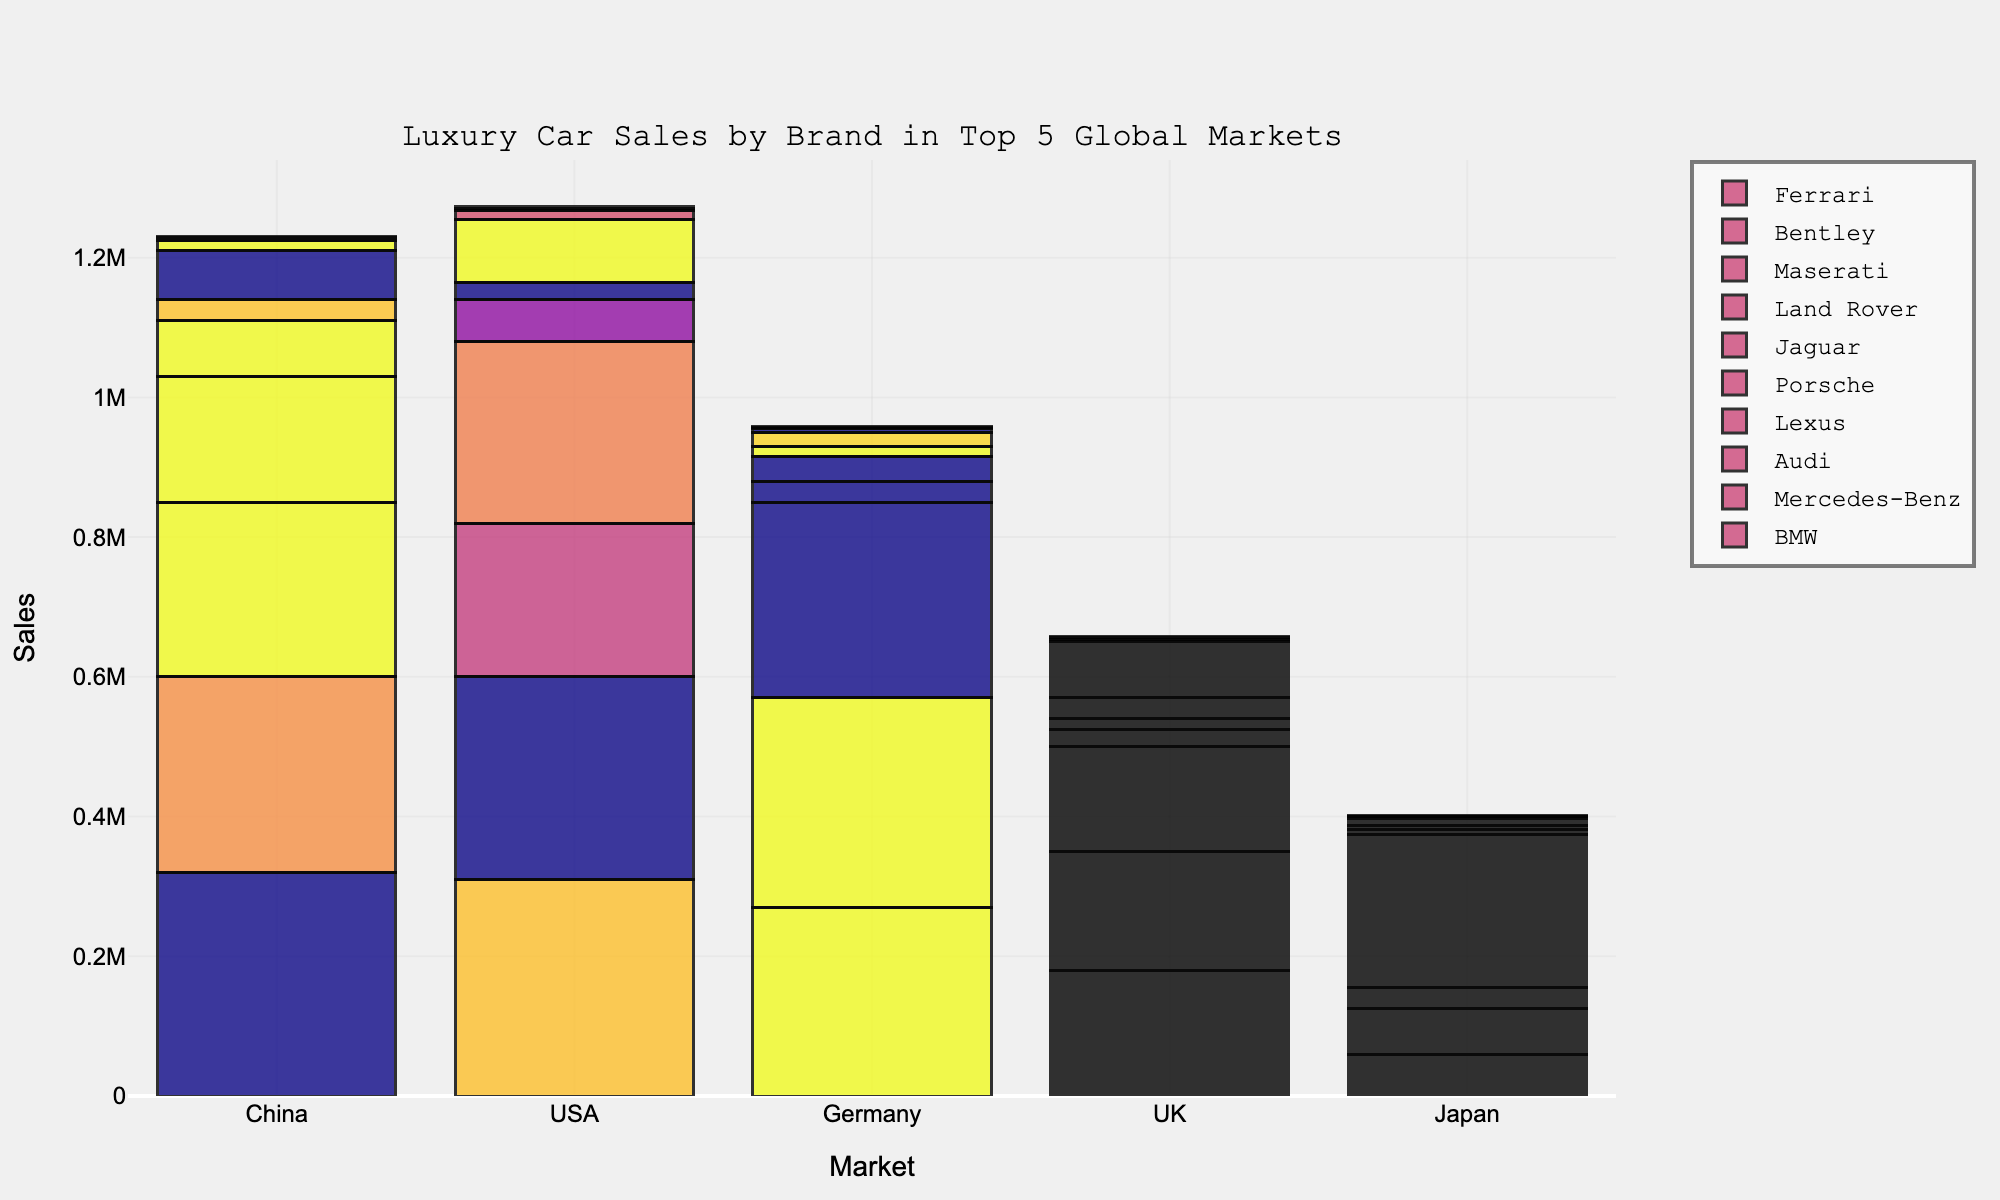What is the total number of luxury cars sold by BMW across the top 5 global markets? Add up BMW sales in China, USA, Germany, UK, and Japan: (320,000 + 310,000 + 270,000 + 180,000 + 60,000)
Answer: 1,140,000 Which brand has the highest sales in Japan? Check the sales figures for all brands in Japan; Lexus has the highest with 220,000 units.
Answer: Lexus How do Porsche's sales in the USA compare to its sales in Germany? Compare Porsche's sales in the USA (60,000) to its sales in Germany (35,000); 60,000 is greater than 35,000.
Answer: Higher What is the average number of luxury cars sold by Jaguar in all top 5 markets? Sum Jaguar's sales in all markets and divide by the number of markets: (30,000 + 25,000 + 15,000 + 30,000 + 5,000) / 5
Answer: 21,000 Which market has the lowest sales for Bentley? Compare Bentley's sales across all markets and find the lowest value, which is in Japan (500).
Answer: Japan What is the combined total sales of Ferrari and Maserati in China? Add sales of Ferrari (2,500) and Maserati (15,000) in China: (2,500 + 15,000)
Answer: 17,500 Which brand's bar has the most prominent color in China? Identify the tallest bar in China's segment, which corresponds to BMW.
Answer: BMW Does Land Rover sell more cars in the UK or USA? Compare Land Rover sales in the UK (80,000) and USA (90,000); 90,000 is greater than 80,000.
Answer: USA What is the total number of Mercedes-Benz cars sold in Europe (Germany and UK)? Add Mercedes-Benz sales in Germany and UK: (300,000 + 170,000)
Answer: 470,000 Compare Audi's sales in the USA and Japan. Which market has higher sales? Check Audi's sales in the USA (220,000) and Japan (30,000); 220,000 is greater than 30,000.
Answer: USA 